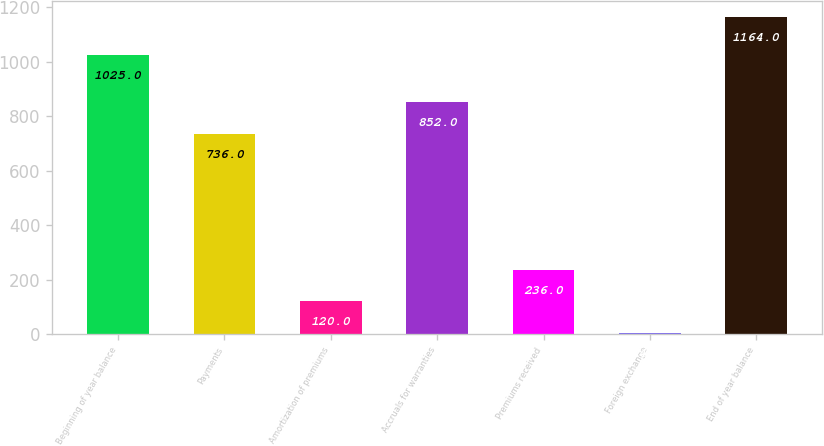Convert chart to OTSL. <chart><loc_0><loc_0><loc_500><loc_500><bar_chart><fcel>Beginning of year balance<fcel>Payments<fcel>Amortization of premiums<fcel>Accruals for warranties<fcel>Premiums received<fcel>Foreign exchange<fcel>End of year balance<nl><fcel>1025<fcel>736<fcel>120<fcel>852<fcel>236<fcel>4<fcel>1164<nl></chart> 